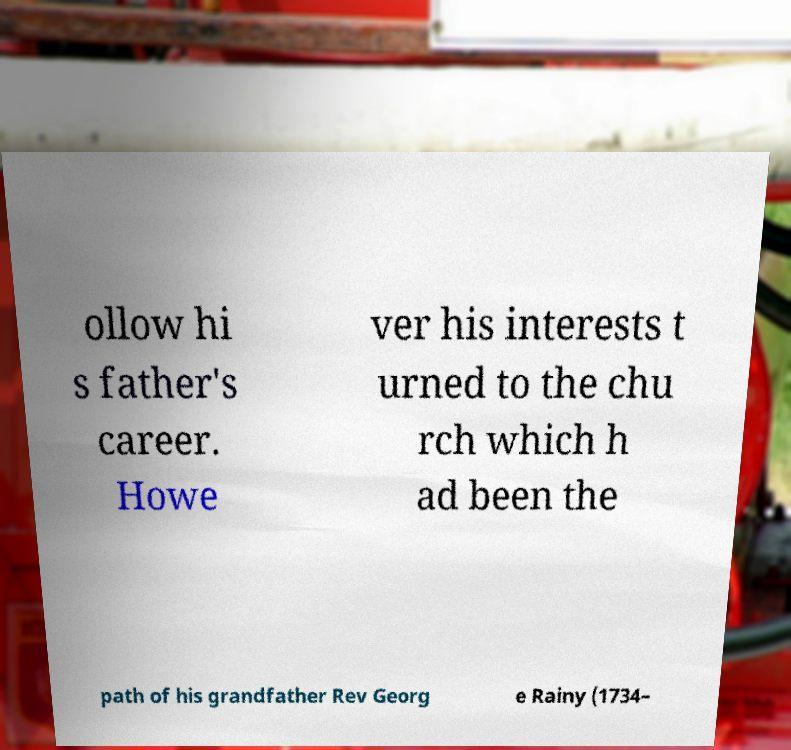For documentation purposes, I need the text within this image transcribed. Could you provide that? ollow hi s father's career. Howe ver his interests t urned to the chu rch which h ad been the path of his grandfather Rev Georg e Rainy (1734– 